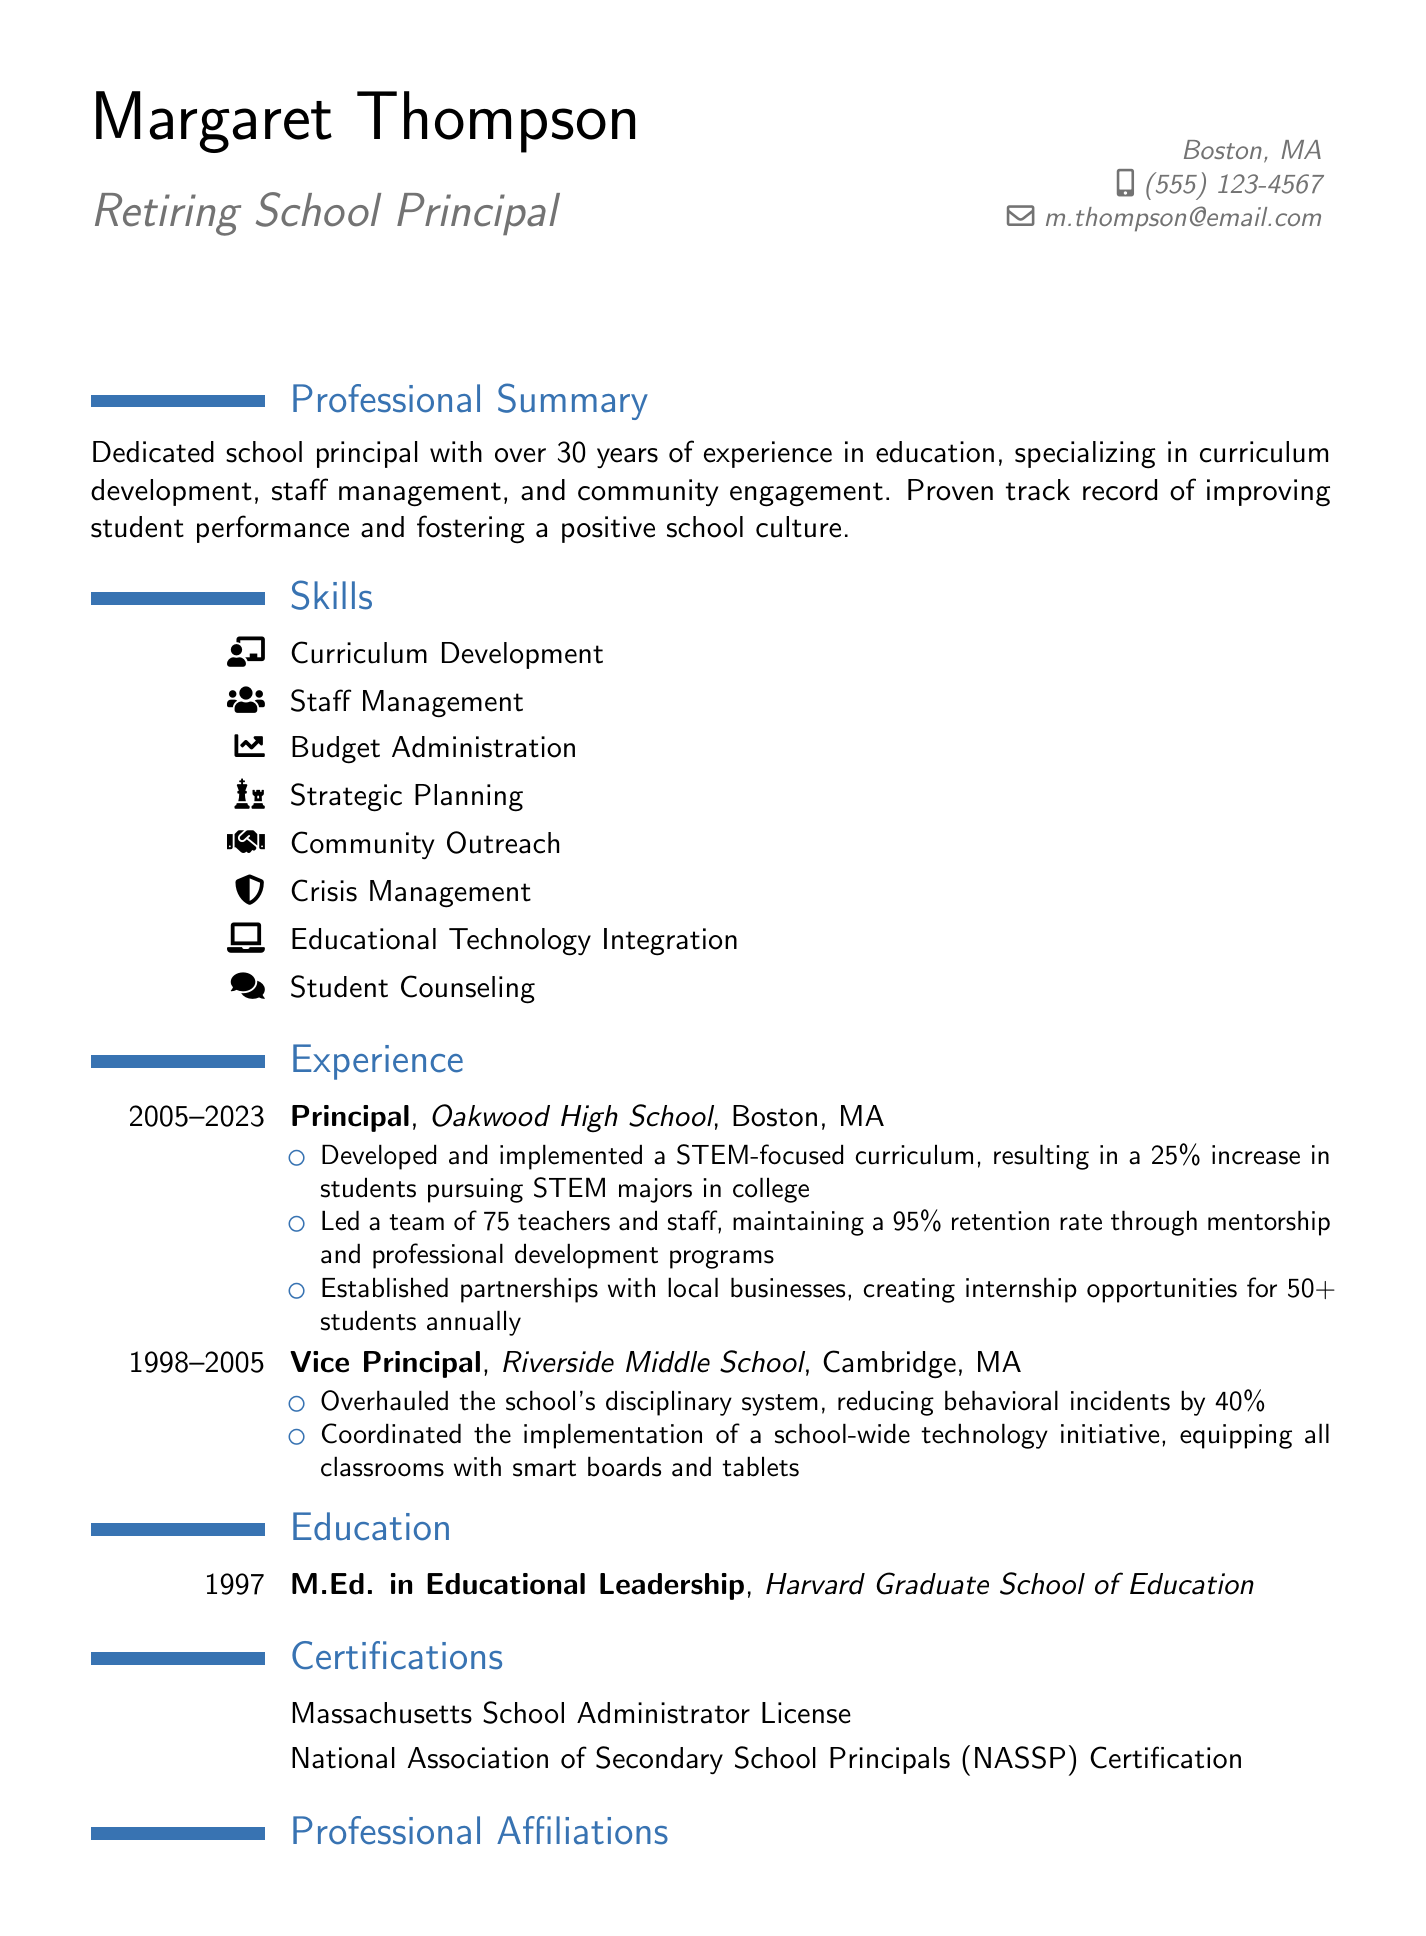What is the name of the principal? The document lists the principal's name as Margaret Thompson.
Answer: Margaret Thompson What is Margaret Thompson's email address? The email address provided for Margaret Thompson in the document is m.thompson@email.com.
Answer: m.thompson@email.com How many years of experience does Margaret Thompson have? The document states that she has over 30 years of experience in education.
Answer: over 30 years Which school did she serve as principal? The document indicates that she served as principal at Oakwood High School.
Answer: Oakwood High School What was one of the achievements at Oakwood High School? The document mentions that she developed a STEM-focused curriculum, resulting in a 25% increase in students pursuing STEM majors.
Answer: 25% increase in students pursuing STEM majors What is the degree held by Margaret Thompson? The document lists her degree as M.Ed. in Educational Leadership.
Answer: M.Ed. in Educational Leadership Which certification does she hold? The document mentions her certification as Massachusetts School Administrator License.
Answer: Massachusetts School Administrator License What was a key focus area during her tenure as a vice principal? One focus area mentioned was overhauling the school's disciplinary system.
Answer: Overhauling the school's disciplinary system How many teachers and staff did Margaret Thompson lead at Oakwood High School? The document states that she led a team of 75 teachers and staff at Oakwood High School.
Answer: 75 teachers and staff 